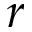<formula> <loc_0><loc_0><loc_500><loc_500>r</formula> 